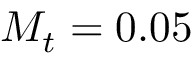<formula> <loc_0><loc_0><loc_500><loc_500>M _ { t } = 0 . 0 5</formula> 